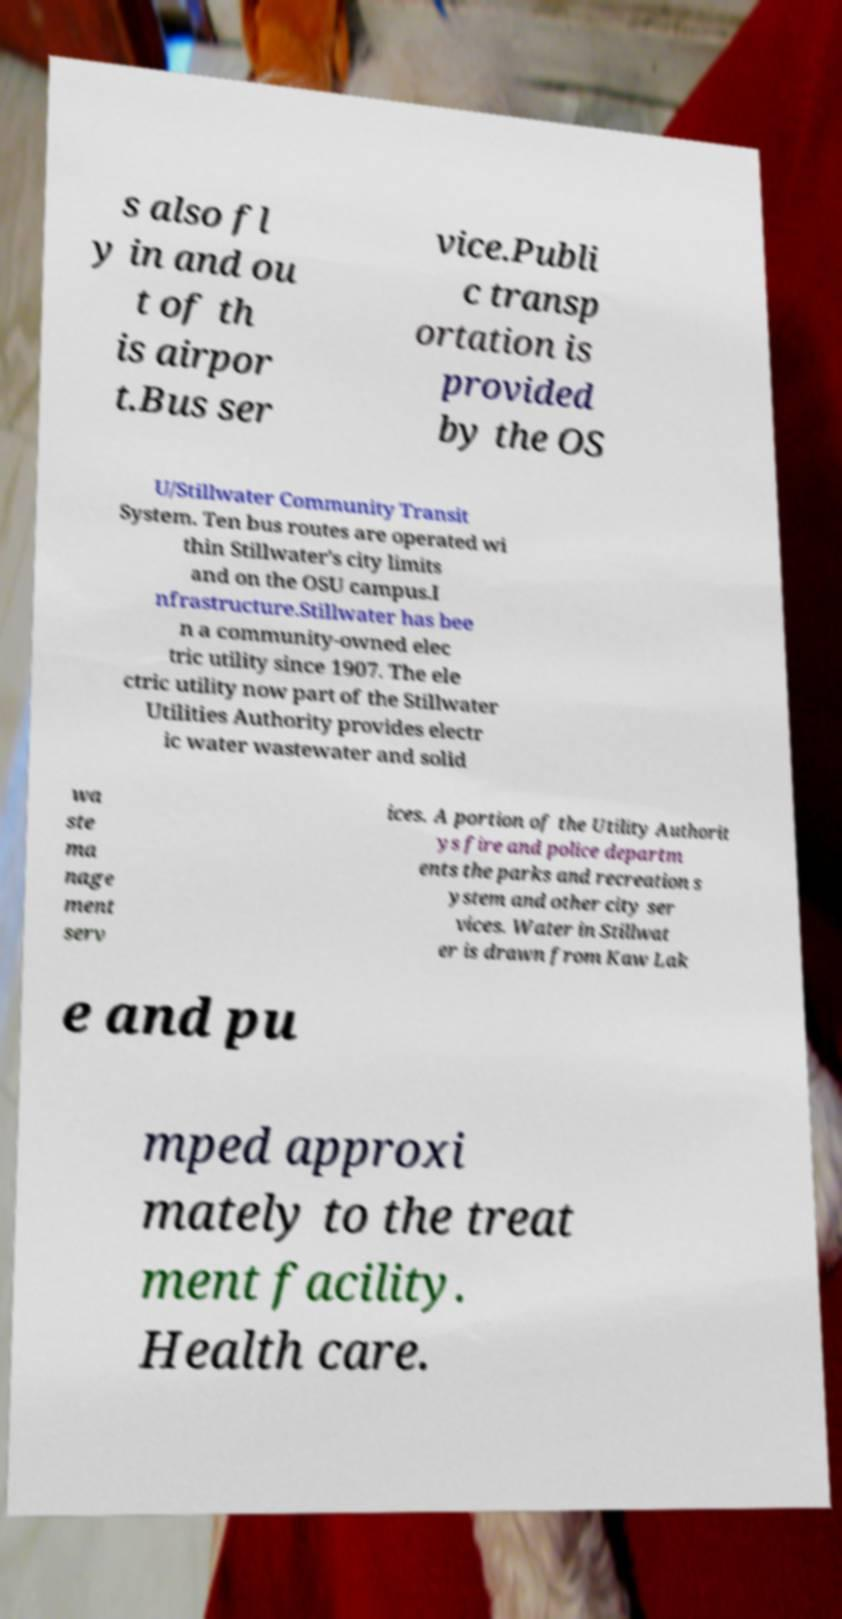For documentation purposes, I need the text within this image transcribed. Could you provide that? s also fl y in and ou t of th is airpor t.Bus ser vice.Publi c transp ortation is provided by the OS U/Stillwater Community Transit System. Ten bus routes are operated wi thin Stillwater's city limits and on the OSU campus.I nfrastructure.Stillwater has bee n a community-owned elec tric utility since 1907. The ele ctric utility now part of the Stillwater Utilities Authority provides electr ic water wastewater and solid wa ste ma nage ment serv ices. A portion of the Utility Authorit ys fire and police departm ents the parks and recreation s ystem and other city ser vices. Water in Stillwat er is drawn from Kaw Lak e and pu mped approxi mately to the treat ment facility. Health care. 